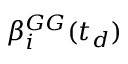Convert formula to latex. <formula><loc_0><loc_0><loc_500><loc_500>\beta _ { i } ^ { G G } ( t _ { d } )</formula> 